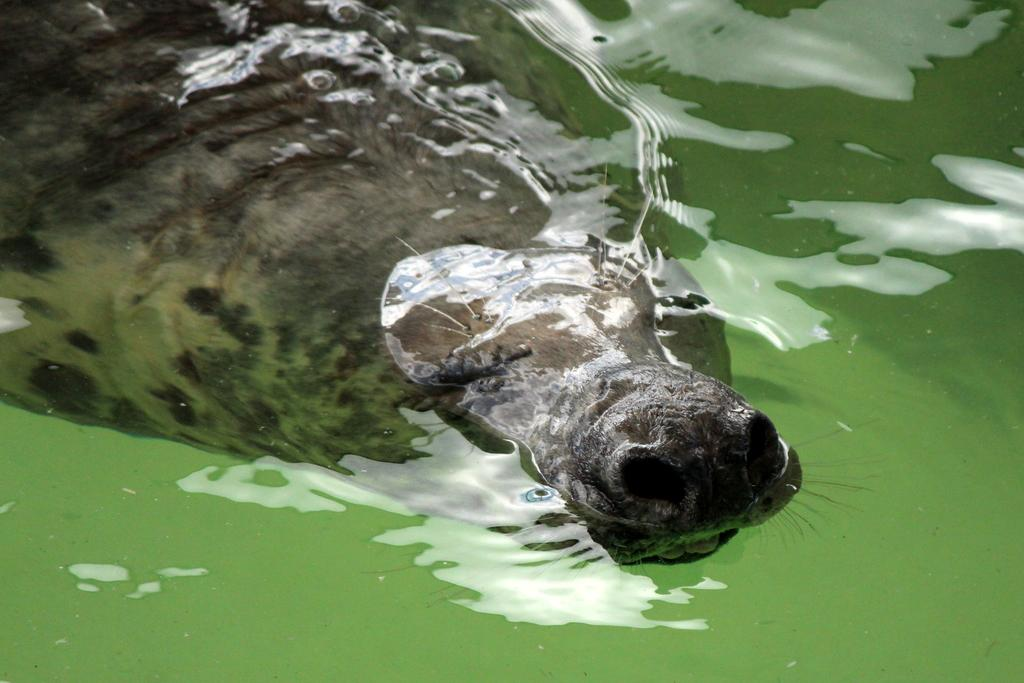What type of animal is in the image? There is an animal in the image, but the specific type cannot be determined from the provided facts. Where is the animal located in the image? The animal is in the water. What type of company is the goldfish working for in the image? There is no goldfish or company present in the image. How many ducks are visible in the image? There is no mention of ducks in the provided facts, so we cannot determine their presence or quantity in the image. 